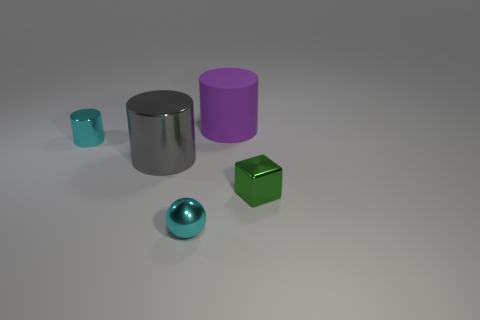Subtract all cylinders. How many objects are left? 2 Subtract 1 cubes. How many cubes are left? 0 Subtract all blue cylinders. Subtract all green cubes. How many cylinders are left? 3 Subtract all green blocks. How many purple cylinders are left? 1 Subtract all big purple things. Subtract all big purple cylinders. How many objects are left? 3 Add 1 metal cubes. How many metal cubes are left? 2 Add 3 large cyan rubber cylinders. How many large cyan rubber cylinders exist? 3 Add 1 big purple rubber cylinders. How many objects exist? 6 Subtract all cyan cylinders. How many cylinders are left? 2 Subtract all tiny metal cylinders. How many cylinders are left? 2 